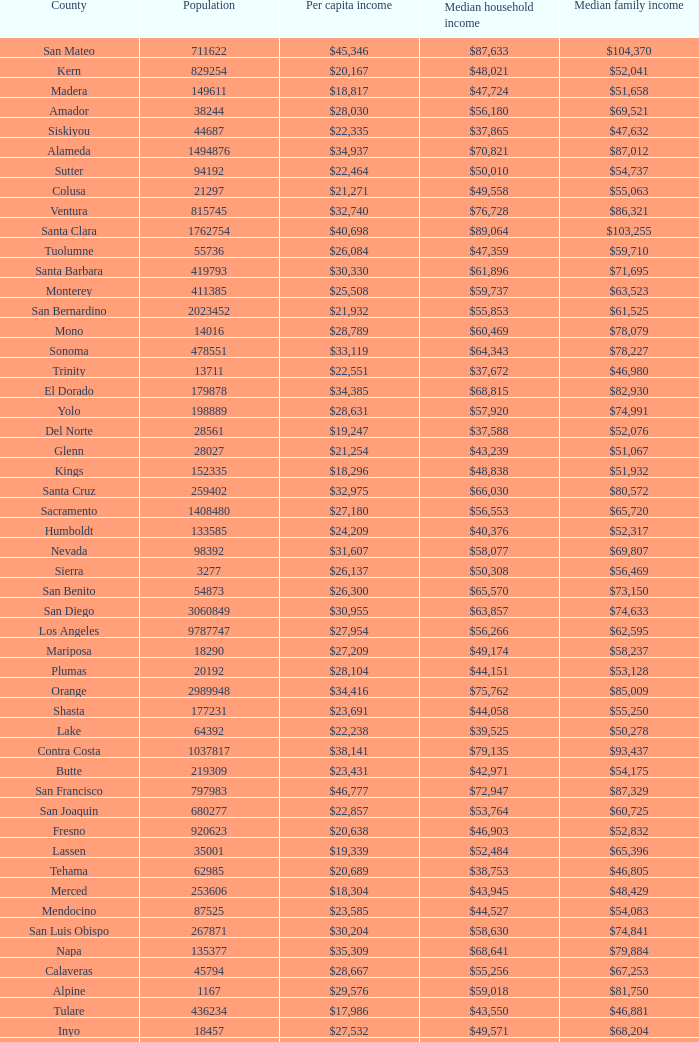What is the median household income of butte? $42,971. 